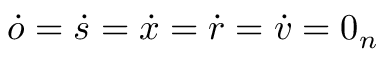Convert formula to latex. <formula><loc_0><loc_0><loc_500><loc_500>\dot { o } = \dot { s } = \dot { x } = \dot { r } = \dot { v } = 0 _ { n }</formula> 